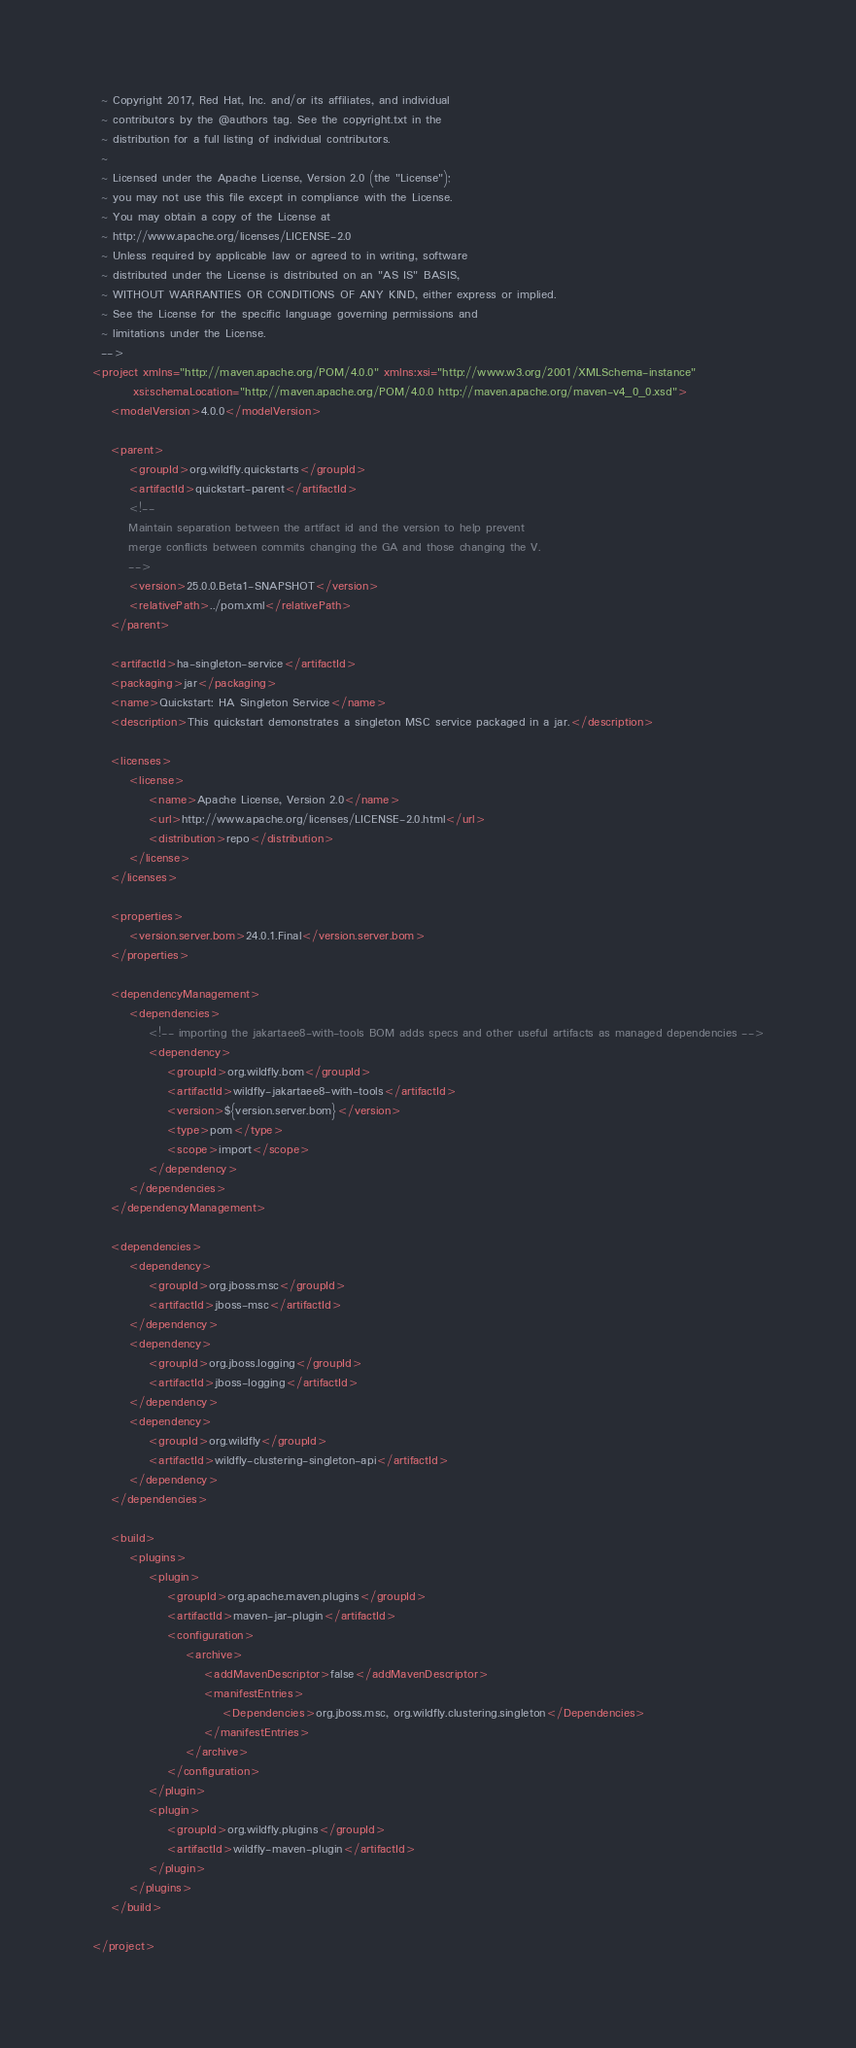Convert code to text. <code><loc_0><loc_0><loc_500><loc_500><_XML_>  ~ Copyright 2017, Red Hat, Inc. and/or its affiliates, and individual
  ~ contributors by the @authors tag. See the copyright.txt in the
  ~ distribution for a full listing of individual contributors.
  ~
  ~ Licensed under the Apache License, Version 2.0 (the "License");
  ~ you may not use this file except in compliance with the License.
  ~ You may obtain a copy of the License at
  ~ http://www.apache.org/licenses/LICENSE-2.0
  ~ Unless required by applicable law or agreed to in writing, software
  ~ distributed under the License is distributed on an "AS IS" BASIS,
  ~ WITHOUT WARRANTIES OR CONDITIONS OF ANY KIND, either express or implied.
  ~ See the License for the specific language governing permissions and
  ~ limitations under the License.
  -->
<project xmlns="http://maven.apache.org/POM/4.0.0" xmlns:xsi="http://www.w3.org/2001/XMLSchema-instance"
         xsi:schemaLocation="http://maven.apache.org/POM/4.0.0 http://maven.apache.org/maven-v4_0_0.xsd">
    <modelVersion>4.0.0</modelVersion>

    <parent>
        <groupId>org.wildfly.quickstarts</groupId>
        <artifactId>quickstart-parent</artifactId>
        <!--
        Maintain separation between the artifact id and the version to help prevent
        merge conflicts between commits changing the GA and those changing the V.
        -->
        <version>25.0.0.Beta1-SNAPSHOT</version>
        <relativePath>../pom.xml</relativePath>
    </parent>

    <artifactId>ha-singleton-service</artifactId>
    <packaging>jar</packaging>
    <name>Quickstart: HA Singleton Service</name>
    <description>This quickstart demonstrates a singleton MSC service packaged in a jar.</description>

    <licenses>
        <license>
            <name>Apache License, Version 2.0</name>
            <url>http://www.apache.org/licenses/LICENSE-2.0.html</url>
            <distribution>repo</distribution>
        </license>
    </licenses>

    <properties>
        <version.server.bom>24.0.1.Final</version.server.bom>
    </properties>

    <dependencyManagement>
        <dependencies>
            <!-- importing the jakartaee8-with-tools BOM adds specs and other useful artifacts as managed dependencies -->
            <dependency>
                <groupId>org.wildfly.bom</groupId>
                <artifactId>wildfly-jakartaee8-with-tools</artifactId>
                <version>${version.server.bom}</version>
                <type>pom</type>
                <scope>import</scope>
            </dependency>
        </dependencies>
    </dependencyManagement>

    <dependencies>
        <dependency>
            <groupId>org.jboss.msc</groupId>
            <artifactId>jboss-msc</artifactId>
        </dependency>
        <dependency>
            <groupId>org.jboss.logging</groupId>
            <artifactId>jboss-logging</artifactId>
        </dependency>
        <dependency>
            <groupId>org.wildfly</groupId>
            <artifactId>wildfly-clustering-singleton-api</artifactId>
        </dependency>
    </dependencies>

    <build>
        <plugins>
            <plugin>
                <groupId>org.apache.maven.plugins</groupId>
                <artifactId>maven-jar-plugin</artifactId>
                <configuration>
                    <archive>
                        <addMavenDescriptor>false</addMavenDescriptor>
                        <manifestEntries>
                            <Dependencies>org.jboss.msc, org.wildfly.clustering.singleton</Dependencies>
                        </manifestEntries>
                    </archive>
                </configuration>
            </plugin>
            <plugin>
                <groupId>org.wildfly.plugins</groupId>
                <artifactId>wildfly-maven-plugin</artifactId>
            </plugin>
        </plugins>
    </build>

</project>
</code> 